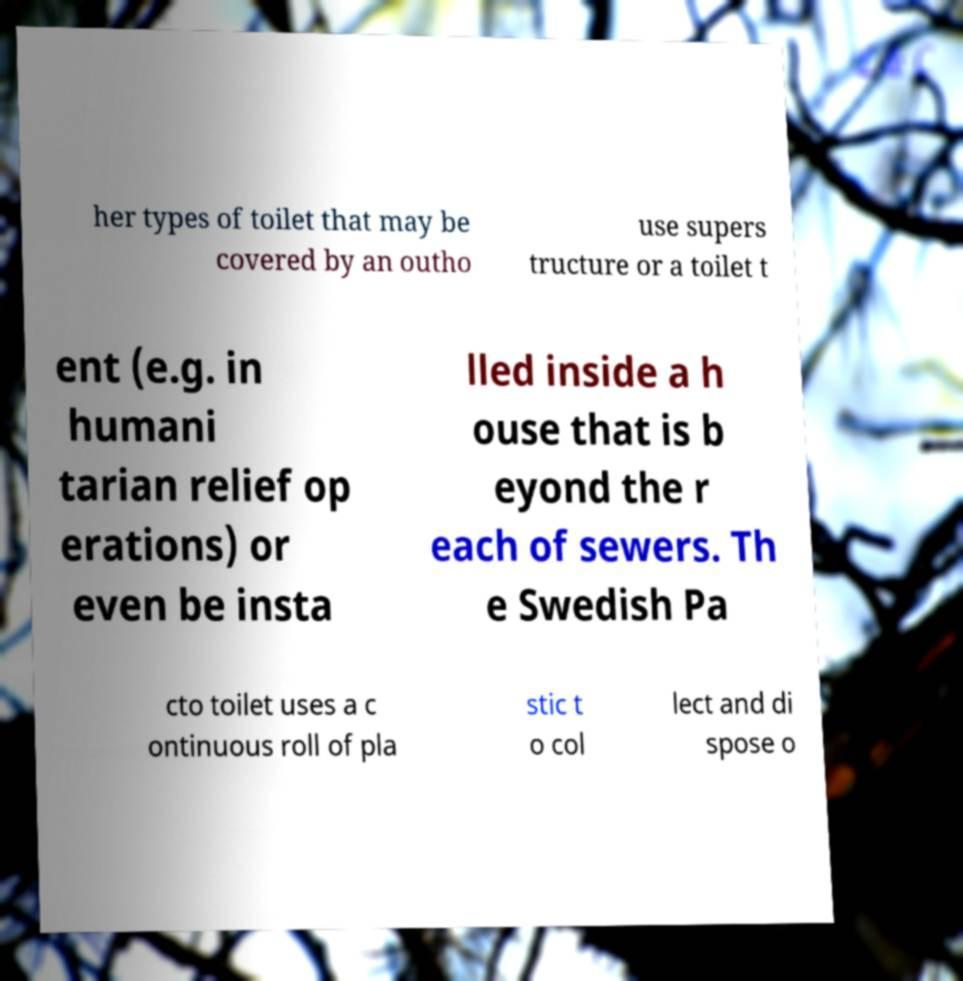Can you read and provide the text displayed in the image?This photo seems to have some interesting text. Can you extract and type it out for me? her types of toilet that may be covered by an outho use supers tructure or a toilet t ent (e.g. in humani tarian relief op erations) or even be insta lled inside a h ouse that is b eyond the r each of sewers. Th e Swedish Pa cto toilet uses a c ontinuous roll of pla stic t o col lect and di spose o 